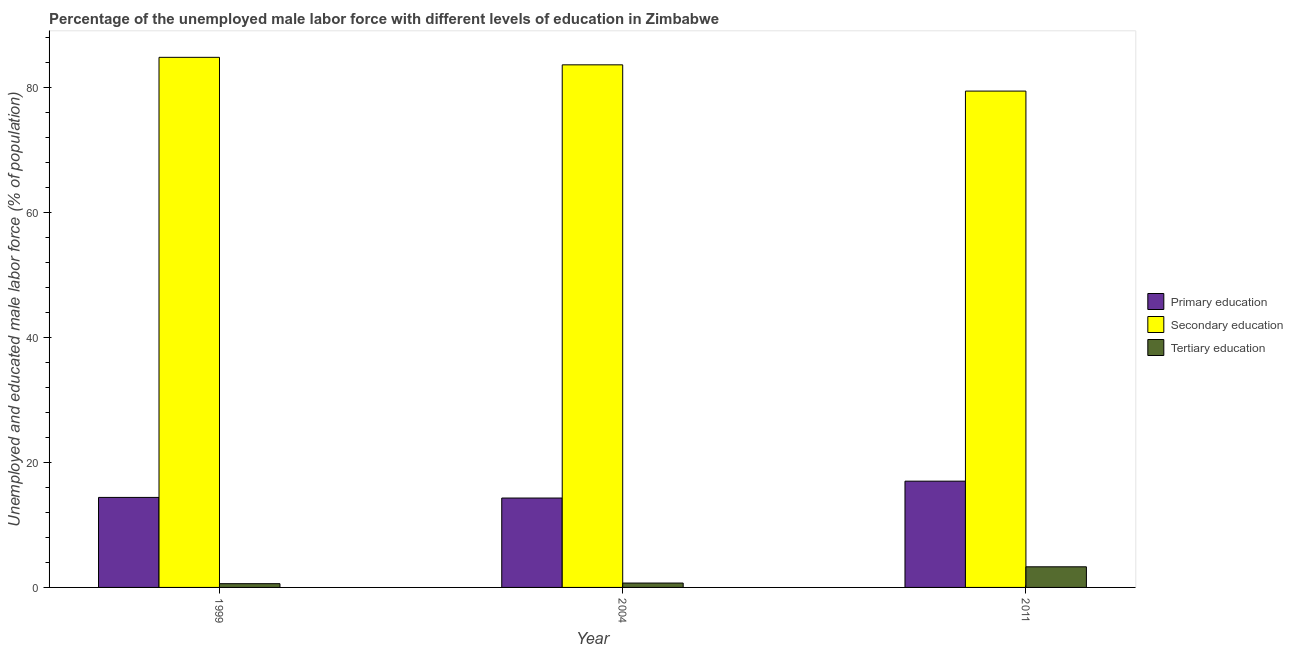How many different coloured bars are there?
Your answer should be very brief. 3. Are the number of bars per tick equal to the number of legend labels?
Make the answer very short. Yes. Are the number of bars on each tick of the X-axis equal?
Provide a short and direct response. Yes. What is the percentage of male labor force who received tertiary education in 1999?
Provide a succinct answer. 0.6. Across all years, what is the maximum percentage of male labor force who received primary education?
Provide a succinct answer. 17. Across all years, what is the minimum percentage of male labor force who received secondary education?
Your response must be concise. 79.4. In which year was the percentage of male labor force who received secondary education maximum?
Give a very brief answer. 1999. In which year was the percentage of male labor force who received primary education minimum?
Make the answer very short. 2004. What is the total percentage of male labor force who received primary education in the graph?
Offer a terse response. 45.7. What is the difference between the percentage of male labor force who received primary education in 2004 and that in 2011?
Provide a succinct answer. -2.7. What is the difference between the percentage of male labor force who received tertiary education in 1999 and the percentage of male labor force who received primary education in 2004?
Your answer should be compact. -0.1. What is the average percentage of male labor force who received primary education per year?
Make the answer very short. 15.23. In the year 2011, what is the difference between the percentage of male labor force who received secondary education and percentage of male labor force who received tertiary education?
Your answer should be very brief. 0. What is the ratio of the percentage of male labor force who received secondary education in 1999 to that in 2004?
Make the answer very short. 1.01. Is the difference between the percentage of male labor force who received tertiary education in 1999 and 2011 greater than the difference between the percentage of male labor force who received secondary education in 1999 and 2011?
Your answer should be very brief. No. What is the difference between the highest and the second highest percentage of male labor force who received primary education?
Provide a succinct answer. 2.6. What is the difference between the highest and the lowest percentage of male labor force who received secondary education?
Your response must be concise. 5.4. Is the sum of the percentage of male labor force who received primary education in 2004 and 2011 greater than the maximum percentage of male labor force who received tertiary education across all years?
Your answer should be very brief. Yes. What does the 2nd bar from the left in 1999 represents?
Provide a succinct answer. Secondary education. What does the 3rd bar from the right in 2011 represents?
Ensure brevity in your answer.  Primary education. How many bars are there?
Provide a short and direct response. 9. How many years are there in the graph?
Make the answer very short. 3. Are the values on the major ticks of Y-axis written in scientific E-notation?
Offer a very short reply. No. Does the graph contain grids?
Provide a short and direct response. No. How are the legend labels stacked?
Offer a very short reply. Vertical. What is the title of the graph?
Keep it short and to the point. Percentage of the unemployed male labor force with different levels of education in Zimbabwe. Does "Coal sources" appear as one of the legend labels in the graph?
Offer a very short reply. No. What is the label or title of the Y-axis?
Provide a succinct answer. Unemployed and educated male labor force (% of population). What is the Unemployed and educated male labor force (% of population) in Primary education in 1999?
Your answer should be compact. 14.4. What is the Unemployed and educated male labor force (% of population) in Secondary education in 1999?
Make the answer very short. 84.8. What is the Unemployed and educated male labor force (% of population) in Tertiary education in 1999?
Make the answer very short. 0.6. What is the Unemployed and educated male labor force (% of population) of Primary education in 2004?
Your answer should be very brief. 14.3. What is the Unemployed and educated male labor force (% of population) in Secondary education in 2004?
Make the answer very short. 83.6. What is the Unemployed and educated male labor force (% of population) of Tertiary education in 2004?
Make the answer very short. 0.7. What is the Unemployed and educated male labor force (% of population) in Primary education in 2011?
Offer a very short reply. 17. What is the Unemployed and educated male labor force (% of population) in Secondary education in 2011?
Make the answer very short. 79.4. What is the Unemployed and educated male labor force (% of population) of Tertiary education in 2011?
Provide a succinct answer. 3.3. Across all years, what is the maximum Unemployed and educated male labor force (% of population) in Secondary education?
Your response must be concise. 84.8. Across all years, what is the maximum Unemployed and educated male labor force (% of population) of Tertiary education?
Make the answer very short. 3.3. Across all years, what is the minimum Unemployed and educated male labor force (% of population) in Primary education?
Your response must be concise. 14.3. Across all years, what is the minimum Unemployed and educated male labor force (% of population) in Secondary education?
Offer a very short reply. 79.4. Across all years, what is the minimum Unemployed and educated male labor force (% of population) of Tertiary education?
Make the answer very short. 0.6. What is the total Unemployed and educated male labor force (% of population) of Primary education in the graph?
Offer a terse response. 45.7. What is the total Unemployed and educated male labor force (% of population) of Secondary education in the graph?
Offer a very short reply. 247.8. What is the difference between the Unemployed and educated male labor force (% of population) in Primary education in 1999 and that in 2004?
Your response must be concise. 0.1. What is the difference between the Unemployed and educated male labor force (% of population) in Tertiary education in 1999 and that in 2004?
Make the answer very short. -0.1. What is the difference between the Unemployed and educated male labor force (% of population) in Secondary education in 1999 and that in 2011?
Give a very brief answer. 5.4. What is the difference between the Unemployed and educated male labor force (% of population) in Secondary education in 2004 and that in 2011?
Give a very brief answer. 4.2. What is the difference between the Unemployed and educated male labor force (% of population) of Tertiary education in 2004 and that in 2011?
Provide a succinct answer. -2.6. What is the difference between the Unemployed and educated male labor force (% of population) of Primary education in 1999 and the Unemployed and educated male labor force (% of population) of Secondary education in 2004?
Your answer should be very brief. -69.2. What is the difference between the Unemployed and educated male labor force (% of population) in Primary education in 1999 and the Unemployed and educated male labor force (% of population) in Tertiary education in 2004?
Give a very brief answer. 13.7. What is the difference between the Unemployed and educated male labor force (% of population) in Secondary education in 1999 and the Unemployed and educated male labor force (% of population) in Tertiary education in 2004?
Offer a terse response. 84.1. What is the difference between the Unemployed and educated male labor force (% of population) in Primary education in 1999 and the Unemployed and educated male labor force (% of population) in Secondary education in 2011?
Give a very brief answer. -65. What is the difference between the Unemployed and educated male labor force (% of population) in Secondary education in 1999 and the Unemployed and educated male labor force (% of population) in Tertiary education in 2011?
Provide a short and direct response. 81.5. What is the difference between the Unemployed and educated male labor force (% of population) of Primary education in 2004 and the Unemployed and educated male labor force (% of population) of Secondary education in 2011?
Make the answer very short. -65.1. What is the difference between the Unemployed and educated male labor force (% of population) of Secondary education in 2004 and the Unemployed and educated male labor force (% of population) of Tertiary education in 2011?
Keep it short and to the point. 80.3. What is the average Unemployed and educated male labor force (% of population) of Primary education per year?
Provide a succinct answer. 15.23. What is the average Unemployed and educated male labor force (% of population) of Secondary education per year?
Offer a very short reply. 82.6. What is the average Unemployed and educated male labor force (% of population) of Tertiary education per year?
Provide a short and direct response. 1.53. In the year 1999, what is the difference between the Unemployed and educated male labor force (% of population) in Primary education and Unemployed and educated male labor force (% of population) in Secondary education?
Provide a succinct answer. -70.4. In the year 1999, what is the difference between the Unemployed and educated male labor force (% of population) of Primary education and Unemployed and educated male labor force (% of population) of Tertiary education?
Offer a very short reply. 13.8. In the year 1999, what is the difference between the Unemployed and educated male labor force (% of population) in Secondary education and Unemployed and educated male labor force (% of population) in Tertiary education?
Provide a short and direct response. 84.2. In the year 2004, what is the difference between the Unemployed and educated male labor force (% of population) in Primary education and Unemployed and educated male labor force (% of population) in Secondary education?
Your response must be concise. -69.3. In the year 2004, what is the difference between the Unemployed and educated male labor force (% of population) in Secondary education and Unemployed and educated male labor force (% of population) in Tertiary education?
Offer a very short reply. 82.9. In the year 2011, what is the difference between the Unemployed and educated male labor force (% of population) of Primary education and Unemployed and educated male labor force (% of population) of Secondary education?
Your answer should be very brief. -62.4. In the year 2011, what is the difference between the Unemployed and educated male labor force (% of population) of Primary education and Unemployed and educated male labor force (% of population) of Tertiary education?
Give a very brief answer. 13.7. In the year 2011, what is the difference between the Unemployed and educated male labor force (% of population) in Secondary education and Unemployed and educated male labor force (% of population) in Tertiary education?
Your response must be concise. 76.1. What is the ratio of the Unemployed and educated male labor force (% of population) of Primary education in 1999 to that in 2004?
Give a very brief answer. 1.01. What is the ratio of the Unemployed and educated male labor force (% of population) in Secondary education in 1999 to that in 2004?
Offer a very short reply. 1.01. What is the ratio of the Unemployed and educated male labor force (% of population) in Tertiary education in 1999 to that in 2004?
Ensure brevity in your answer.  0.86. What is the ratio of the Unemployed and educated male labor force (% of population) of Primary education in 1999 to that in 2011?
Your answer should be very brief. 0.85. What is the ratio of the Unemployed and educated male labor force (% of population) of Secondary education in 1999 to that in 2011?
Make the answer very short. 1.07. What is the ratio of the Unemployed and educated male labor force (% of population) in Tertiary education in 1999 to that in 2011?
Your answer should be compact. 0.18. What is the ratio of the Unemployed and educated male labor force (% of population) in Primary education in 2004 to that in 2011?
Make the answer very short. 0.84. What is the ratio of the Unemployed and educated male labor force (% of population) of Secondary education in 2004 to that in 2011?
Ensure brevity in your answer.  1.05. What is the ratio of the Unemployed and educated male labor force (% of population) in Tertiary education in 2004 to that in 2011?
Keep it short and to the point. 0.21. What is the difference between the highest and the second highest Unemployed and educated male labor force (% of population) in Primary education?
Keep it short and to the point. 2.6. What is the difference between the highest and the second highest Unemployed and educated male labor force (% of population) in Secondary education?
Offer a terse response. 1.2. What is the difference between the highest and the second highest Unemployed and educated male labor force (% of population) of Tertiary education?
Your answer should be very brief. 2.6. What is the difference between the highest and the lowest Unemployed and educated male labor force (% of population) in Primary education?
Your answer should be compact. 2.7. What is the difference between the highest and the lowest Unemployed and educated male labor force (% of population) in Secondary education?
Give a very brief answer. 5.4. 